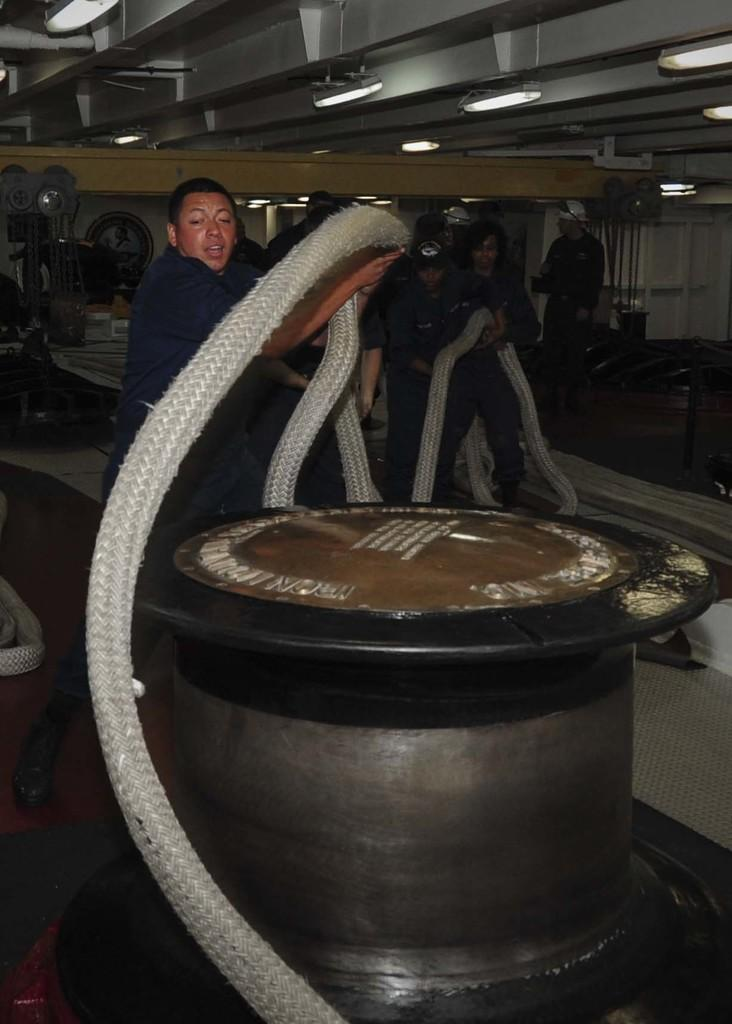What is happening with the group of people in the image? The people are standing and holding a rope in the image. What can be seen in the background of the image? There are lights and objects in the background of the image. What song is the group of people singing in the image? There is no indication in the image that the group of people is singing a song. 